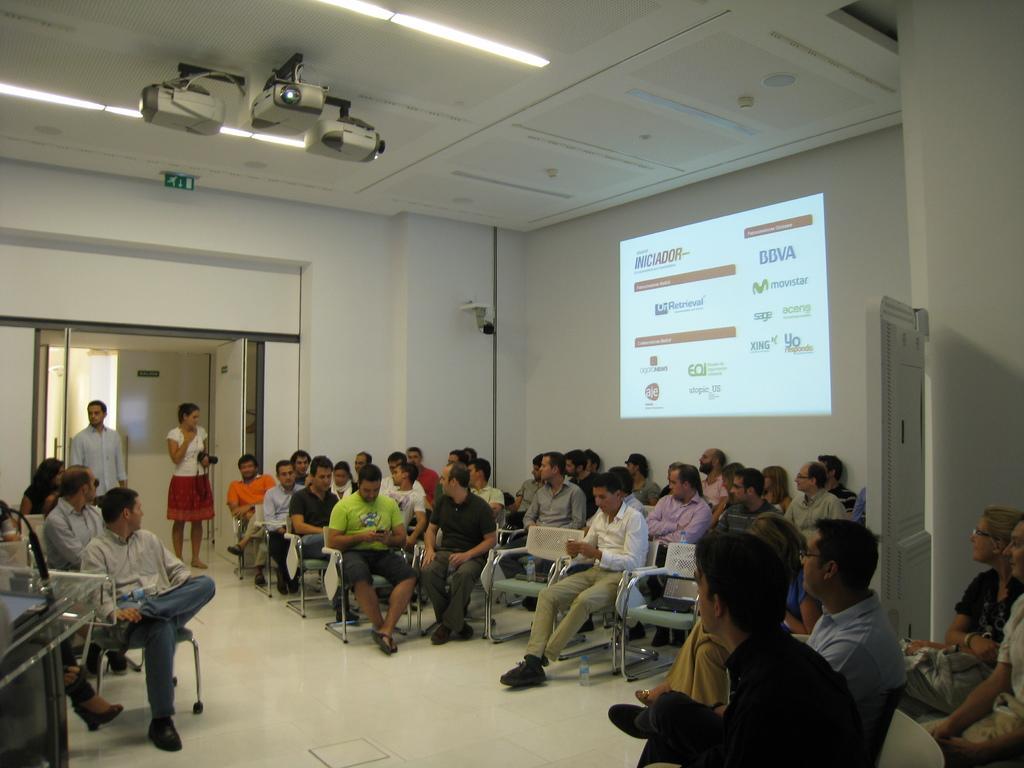Could you give a brief overview of what you see in this image? In this image we can see some persons, chairs, camera, bottle and other objects. In the background of the image there is the wall, door, projector screen and other objects. On the left side of the image there is an object. On the right side of the image there are some persons. At the bottom of the image there is the floor. At the top of the image there is the ceiling, lights, projector and other objects. 